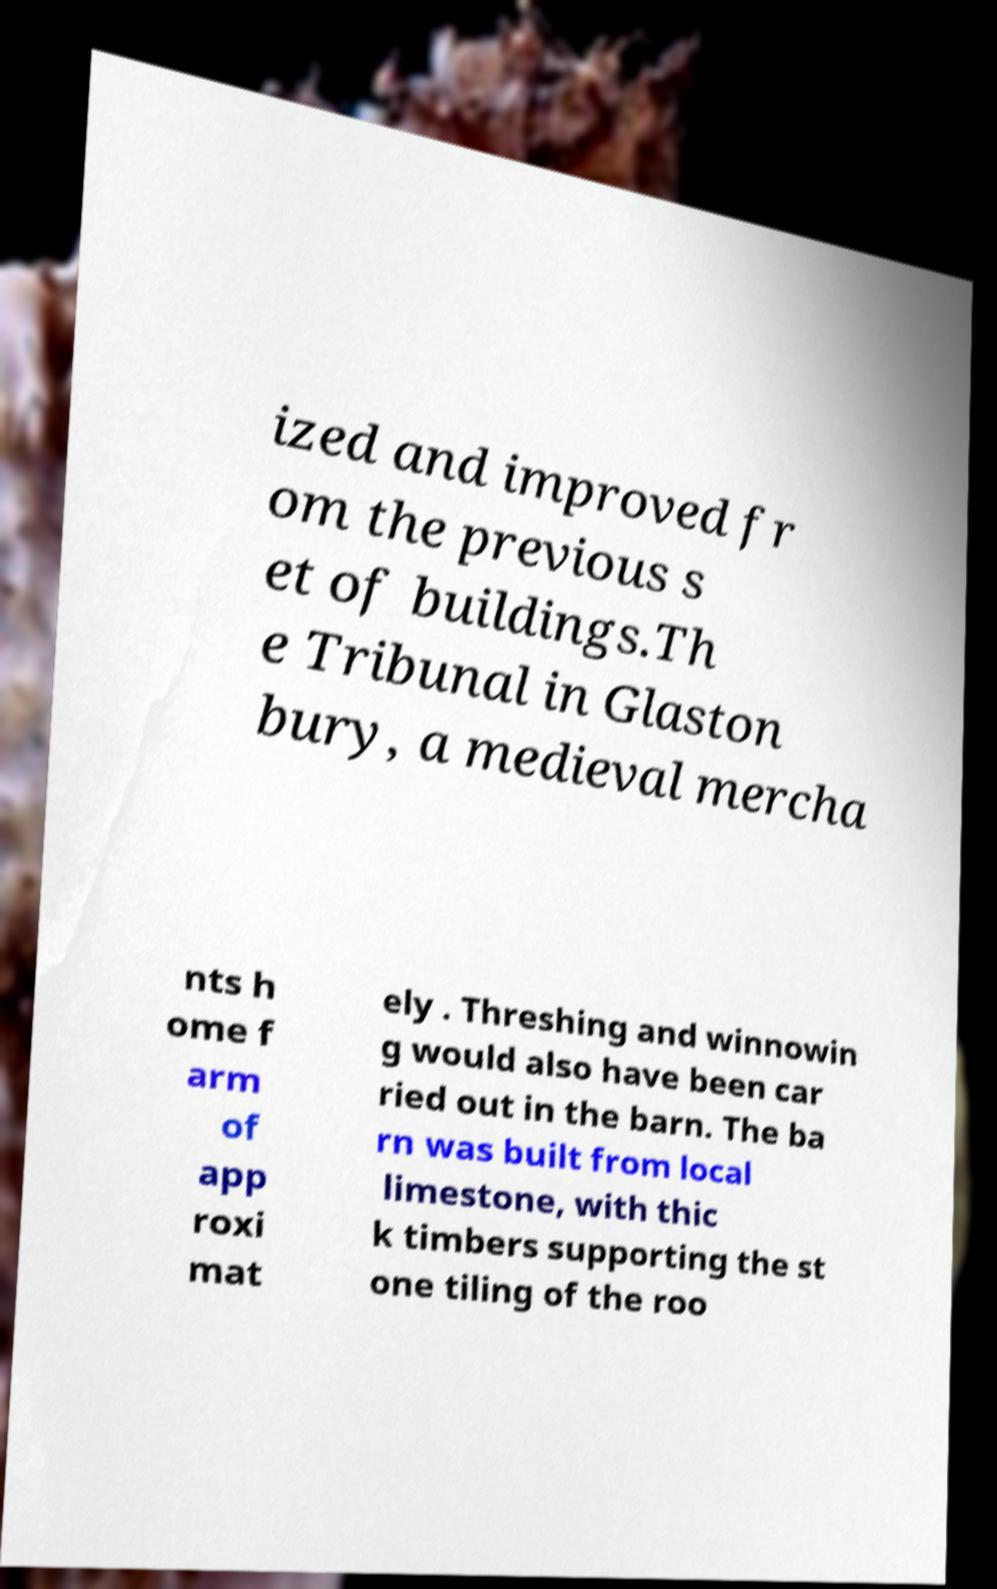What messages or text are displayed in this image? I need them in a readable, typed format. ized and improved fr om the previous s et of buildings.Th e Tribunal in Glaston bury, a medieval mercha nts h ome f arm of app roxi mat ely . Threshing and winnowin g would also have been car ried out in the barn. The ba rn was built from local limestone, with thic k timbers supporting the st one tiling of the roo 